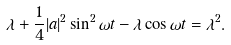<formula> <loc_0><loc_0><loc_500><loc_500>\lambda + \frac { 1 } { 4 } | a | ^ { 2 } \sin ^ { 2 } \omega t - \lambda \cos \omega t = \lambda ^ { 2 } .</formula> 